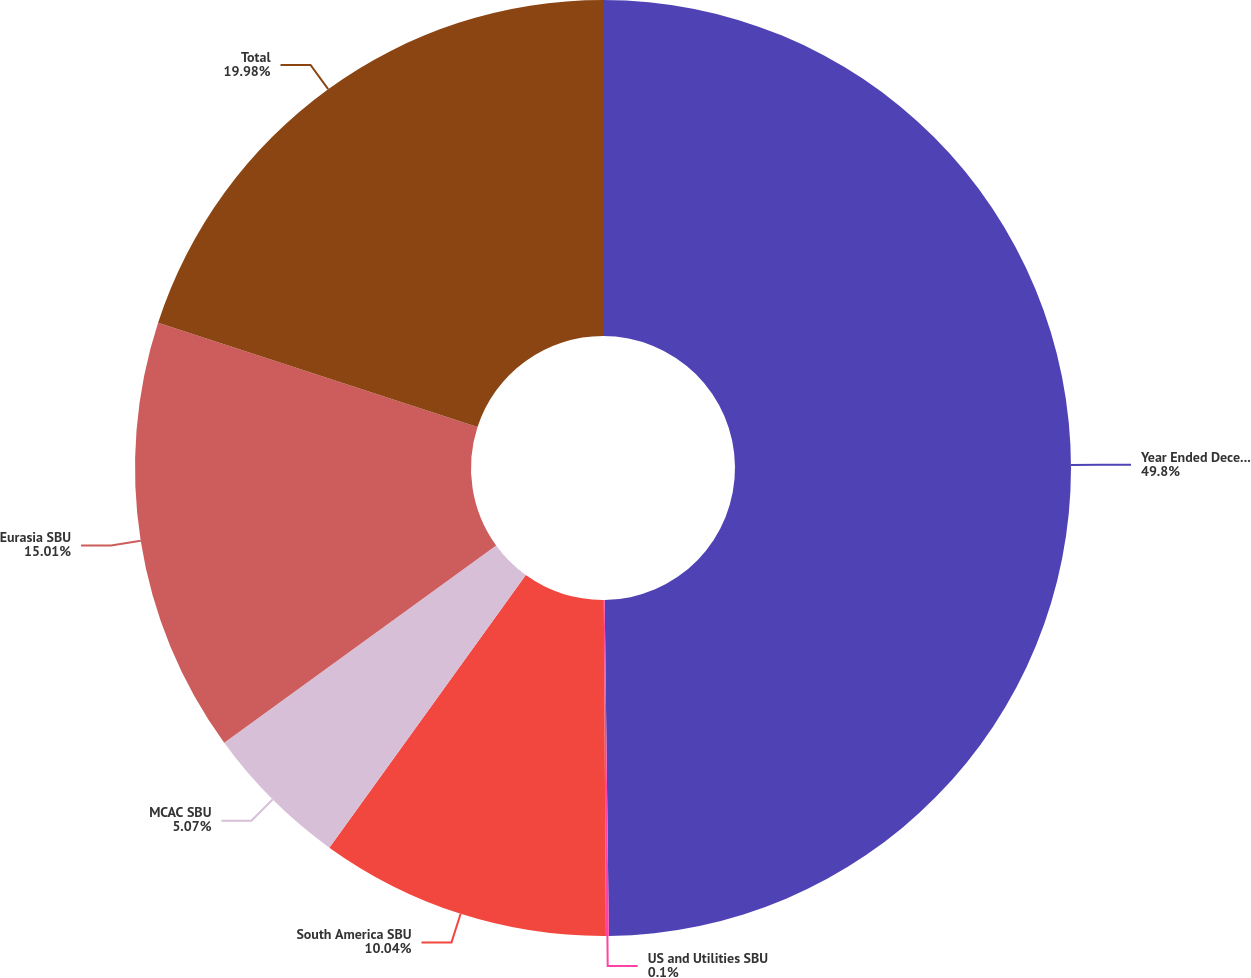<chart> <loc_0><loc_0><loc_500><loc_500><pie_chart><fcel>Year Ended December 31<fcel>US and Utilities SBU<fcel>South America SBU<fcel>MCAC SBU<fcel>Eurasia SBU<fcel>Total<nl><fcel>49.8%<fcel>0.1%<fcel>10.04%<fcel>5.07%<fcel>15.01%<fcel>19.98%<nl></chart> 